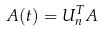<formula> <loc_0><loc_0><loc_500><loc_500>A ( t ) = U _ { n } ^ { T } A</formula> 